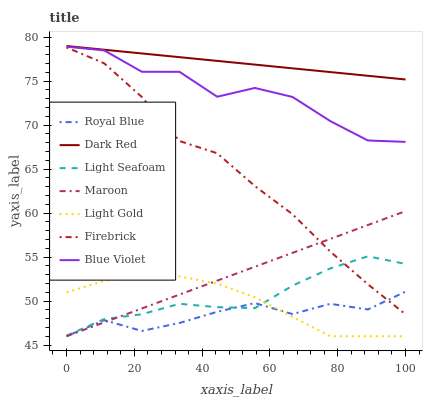Does Firebrick have the minimum area under the curve?
Answer yes or no. No. Does Firebrick have the maximum area under the curve?
Answer yes or no. No. Is Firebrick the smoothest?
Answer yes or no. No. Is Firebrick the roughest?
Answer yes or no. No. Does Firebrick have the lowest value?
Answer yes or no. No. Does Firebrick have the highest value?
Answer yes or no. No. Is Light Seafoam less than Dark Red?
Answer yes or no. Yes. Is Firebrick greater than Light Gold?
Answer yes or no. Yes. Does Light Seafoam intersect Dark Red?
Answer yes or no. No. 